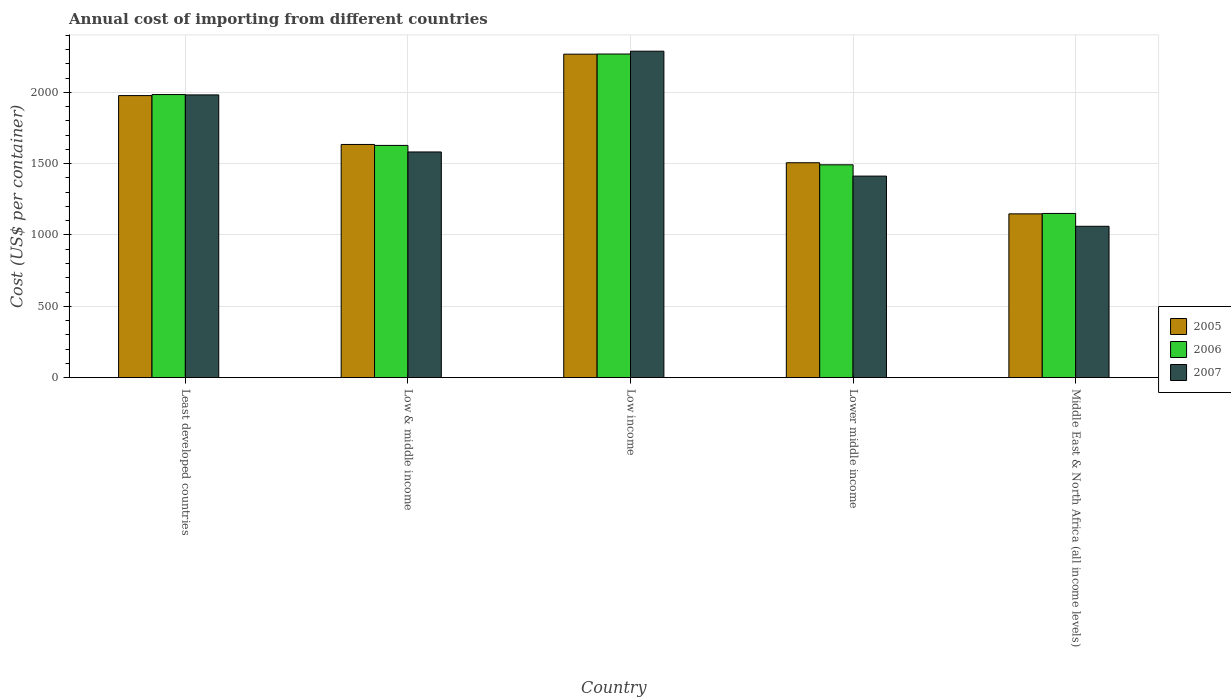How many different coloured bars are there?
Your answer should be compact. 3. How many bars are there on the 3rd tick from the right?
Your answer should be very brief. 3. What is the total annual cost of importing in 2006 in Middle East & North Africa (all income levels)?
Offer a terse response. 1151.06. Across all countries, what is the maximum total annual cost of importing in 2007?
Offer a terse response. 2288.29. Across all countries, what is the minimum total annual cost of importing in 2007?
Give a very brief answer. 1061. In which country was the total annual cost of importing in 2005 minimum?
Offer a very short reply. Middle East & North Africa (all income levels). What is the total total annual cost of importing in 2006 in the graph?
Your answer should be compact. 8523.89. What is the difference between the total annual cost of importing in 2007 in Lower middle income and that in Middle East & North Africa (all income levels)?
Offer a very short reply. 351.82. What is the difference between the total annual cost of importing in 2007 in Least developed countries and the total annual cost of importing in 2005 in Middle East & North Africa (all income levels)?
Keep it short and to the point. 833.76. What is the average total annual cost of importing in 2006 per country?
Your answer should be compact. 1704.78. What is the difference between the total annual cost of importing of/in 2005 and total annual cost of importing of/in 2007 in Low & middle income?
Offer a terse response. 52.49. What is the ratio of the total annual cost of importing in 2007 in Least developed countries to that in Middle East & North Africa (all income levels)?
Offer a terse response. 1.87. Is the difference between the total annual cost of importing in 2005 in Least developed countries and Lower middle income greater than the difference between the total annual cost of importing in 2007 in Least developed countries and Lower middle income?
Offer a terse response. No. What is the difference between the highest and the second highest total annual cost of importing in 2006?
Give a very brief answer. 356.5. What is the difference between the highest and the lowest total annual cost of importing in 2005?
Offer a very short reply. 1119.25. In how many countries, is the total annual cost of importing in 2006 greater than the average total annual cost of importing in 2006 taken over all countries?
Provide a short and direct response. 2. What does the 2nd bar from the right in Lower middle income represents?
Make the answer very short. 2006. How many countries are there in the graph?
Your response must be concise. 5. What is the difference between two consecutive major ticks on the Y-axis?
Keep it short and to the point. 500. Are the values on the major ticks of Y-axis written in scientific E-notation?
Your answer should be very brief. No. How many legend labels are there?
Make the answer very short. 3. What is the title of the graph?
Keep it short and to the point. Annual cost of importing from different countries. Does "2007" appear as one of the legend labels in the graph?
Provide a succinct answer. Yes. What is the label or title of the Y-axis?
Your answer should be compact. Cost (US$ per container). What is the Cost (US$ per container) of 2005 in Least developed countries?
Give a very brief answer. 1977.19. What is the Cost (US$ per container) in 2006 in Least developed countries?
Offer a very short reply. 1984.41. What is the Cost (US$ per container) of 2007 in Least developed countries?
Your answer should be very brief. 1982. What is the Cost (US$ per container) of 2005 in Low & middle income?
Your response must be concise. 1634.54. What is the Cost (US$ per container) of 2006 in Low & middle income?
Provide a succinct answer. 1627.91. What is the Cost (US$ per container) in 2007 in Low & middle income?
Give a very brief answer. 1582.06. What is the Cost (US$ per container) of 2005 in Low income?
Offer a very short reply. 2267.48. What is the Cost (US$ per container) of 2006 in Low income?
Offer a very short reply. 2268.46. What is the Cost (US$ per container) of 2007 in Low income?
Ensure brevity in your answer.  2288.29. What is the Cost (US$ per container) of 2005 in Lower middle income?
Offer a very short reply. 1506.43. What is the Cost (US$ per container) in 2006 in Lower middle income?
Your response must be concise. 1492.04. What is the Cost (US$ per container) of 2007 in Lower middle income?
Offer a terse response. 1412.82. What is the Cost (US$ per container) in 2005 in Middle East & North Africa (all income levels)?
Make the answer very short. 1148.24. What is the Cost (US$ per container) in 2006 in Middle East & North Africa (all income levels)?
Provide a short and direct response. 1151.06. What is the Cost (US$ per container) of 2007 in Middle East & North Africa (all income levels)?
Ensure brevity in your answer.  1061. Across all countries, what is the maximum Cost (US$ per container) in 2005?
Offer a very short reply. 2267.48. Across all countries, what is the maximum Cost (US$ per container) of 2006?
Provide a short and direct response. 2268.46. Across all countries, what is the maximum Cost (US$ per container) in 2007?
Offer a terse response. 2288.29. Across all countries, what is the minimum Cost (US$ per container) of 2005?
Give a very brief answer. 1148.24. Across all countries, what is the minimum Cost (US$ per container) in 2006?
Your answer should be compact. 1151.06. Across all countries, what is the minimum Cost (US$ per container) of 2007?
Provide a succinct answer. 1061. What is the total Cost (US$ per container) in 2005 in the graph?
Your response must be concise. 8533.88. What is the total Cost (US$ per container) of 2006 in the graph?
Ensure brevity in your answer.  8523.89. What is the total Cost (US$ per container) in 2007 in the graph?
Your response must be concise. 8326.16. What is the difference between the Cost (US$ per container) in 2005 in Least developed countries and that in Low & middle income?
Your answer should be compact. 342.64. What is the difference between the Cost (US$ per container) of 2006 in Least developed countries and that in Low & middle income?
Keep it short and to the point. 356.5. What is the difference between the Cost (US$ per container) of 2007 in Least developed countries and that in Low & middle income?
Ensure brevity in your answer.  399.94. What is the difference between the Cost (US$ per container) of 2005 in Least developed countries and that in Low income?
Offer a very short reply. -290.3. What is the difference between the Cost (US$ per container) in 2006 in Least developed countries and that in Low income?
Offer a very short reply. -284.06. What is the difference between the Cost (US$ per container) in 2007 in Least developed countries and that in Low income?
Ensure brevity in your answer.  -306.29. What is the difference between the Cost (US$ per container) in 2005 in Least developed countries and that in Lower middle income?
Keep it short and to the point. 470.76. What is the difference between the Cost (US$ per container) of 2006 in Least developed countries and that in Lower middle income?
Ensure brevity in your answer.  492.37. What is the difference between the Cost (US$ per container) of 2007 in Least developed countries and that in Lower middle income?
Provide a short and direct response. 569.18. What is the difference between the Cost (US$ per container) in 2005 in Least developed countries and that in Middle East & North Africa (all income levels)?
Offer a very short reply. 828.95. What is the difference between the Cost (US$ per container) in 2006 in Least developed countries and that in Middle East & North Africa (all income levels)?
Offer a very short reply. 833.35. What is the difference between the Cost (US$ per container) in 2007 in Least developed countries and that in Middle East & North Africa (all income levels)?
Provide a succinct answer. 921. What is the difference between the Cost (US$ per container) of 2005 in Low & middle income and that in Low income?
Offer a terse response. -632.94. What is the difference between the Cost (US$ per container) of 2006 in Low & middle income and that in Low income?
Your response must be concise. -640.55. What is the difference between the Cost (US$ per container) of 2007 in Low & middle income and that in Low income?
Ensure brevity in your answer.  -706.23. What is the difference between the Cost (US$ per container) in 2005 in Low & middle income and that in Lower middle income?
Provide a succinct answer. 128.12. What is the difference between the Cost (US$ per container) of 2006 in Low & middle income and that in Lower middle income?
Provide a succinct answer. 135.87. What is the difference between the Cost (US$ per container) of 2007 in Low & middle income and that in Lower middle income?
Offer a terse response. 169.24. What is the difference between the Cost (US$ per container) of 2005 in Low & middle income and that in Middle East & North Africa (all income levels)?
Give a very brief answer. 486.31. What is the difference between the Cost (US$ per container) of 2006 in Low & middle income and that in Middle East & North Africa (all income levels)?
Provide a succinct answer. 476.85. What is the difference between the Cost (US$ per container) in 2007 in Low & middle income and that in Middle East & North Africa (all income levels)?
Make the answer very short. 521.06. What is the difference between the Cost (US$ per container) of 2005 in Low income and that in Lower middle income?
Provide a short and direct response. 761.05. What is the difference between the Cost (US$ per container) of 2006 in Low income and that in Lower middle income?
Keep it short and to the point. 776.42. What is the difference between the Cost (US$ per container) of 2007 in Low income and that in Lower middle income?
Make the answer very short. 875.47. What is the difference between the Cost (US$ per container) in 2005 in Low income and that in Middle East & North Africa (all income levels)?
Offer a terse response. 1119.25. What is the difference between the Cost (US$ per container) of 2006 in Low income and that in Middle East & North Africa (all income levels)?
Offer a very short reply. 1117.41. What is the difference between the Cost (US$ per container) in 2007 in Low income and that in Middle East & North Africa (all income levels)?
Offer a terse response. 1227.29. What is the difference between the Cost (US$ per container) of 2005 in Lower middle income and that in Middle East & North Africa (all income levels)?
Offer a very short reply. 358.19. What is the difference between the Cost (US$ per container) of 2006 in Lower middle income and that in Middle East & North Africa (all income levels)?
Ensure brevity in your answer.  340.98. What is the difference between the Cost (US$ per container) in 2007 in Lower middle income and that in Middle East & North Africa (all income levels)?
Your answer should be very brief. 351.82. What is the difference between the Cost (US$ per container) in 2005 in Least developed countries and the Cost (US$ per container) in 2006 in Low & middle income?
Provide a short and direct response. 349.27. What is the difference between the Cost (US$ per container) in 2005 in Least developed countries and the Cost (US$ per container) in 2007 in Low & middle income?
Keep it short and to the point. 395.13. What is the difference between the Cost (US$ per container) of 2006 in Least developed countries and the Cost (US$ per container) of 2007 in Low & middle income?
Make the answer very short. 402.35. What is the difference between the Cost (US$ per container) in 2005 in Least developed countries and the Cost (US$ per container) in 2006 in Low income?
Provide a short and direct response. -291.28. What is the difference between the Cost (US$ per container) in 2005 in Least developed countries and the Cost (US$ per container) in 2007 in Low income?
Keep it short and to the point. -311.1. What is the difference between the Cost (US$ per container) of 2006 in Least developed countries and the Cost (US$ per container) of 2007 in Low income?
Keep it short and to the point. -303.88. What is the difference between the Cost (US$ per container) in 2005 in Least developed countries and the Cost (US$ per container) in 2006 in Lower middle income?
Ensure brevity in your answer.  485.15. What is the difference between the Cost (US$ per container) of 2005 in Least developed countries and the Cost (US$ per container) of 2007 in Lower middle income?
Provide a succinct answer. 564.37. What is the difference between the Cost (US$ per container) of 2006 in Least developed countries and the Cost (US$ per container) of 2007 in Lower middle income?
Your answer should be compact. 571.59. What is the difference between the Cost (US$ per container) of 2005 in Least developed countries and the Cost (US$ per container) of 2006 in Middle East & North Africa (all income levels)?
Provide a short and direct response. 826.13. What is the difference between the Cost (US$ per container) in 2005 in Least developed countries and the Cost (US$ per container) in 2007 in Middle East & North Africa (all income levels)?
Your answer should be very brief. 916.19. What is the difference between the Cost (US$ per container) in 2006 in Least developed countries and the Cost (US$ per container) in 2007 in Middle East & North Africa (all income levels)?
Provide a succinct answer. 923.41. What is the difference between the Cost (US$ per container) in 2005 in Low & middle income and the Cost (US$ per container) in 2006 in Low income?
Provide a short and direct response. -633.92. What is the difference between the Cost (US$ per container) in 2005 in Low & middle income and the Cost (US$ per container) in 2007 in Low income?
Give a very brief answer. -653.74. What is the difference between the Cost (US$ per container) of 2006 in Low & middle income and the Cost (US$ per container) of 2007 in Low income?
Offer a very short reply. -660.37. What is the difference between the Cost (US$ per container) of 2005 in Low & middle income and the Cost (US$ per container) of 2006 in Lower middle income?
Ensure brevity in your answer.  142.5. What is the difference between the Cost (US$ per container) in 2005 in Low & middle income and the Cost (US$ per container) in 2007 in Lower middle income?
Provide a succinct answer. 221.73. What is the difference between the Cost (US$ per container) of 2006 in Low & middle income and the Cost (US$ per container) of 2007 in Lower middle income?
Your answer should be compact. 215.1. What is the difference between the Cost (US$ per container) of 2005 in Low & middle income and the Cost (US$ per container) of 2006 in Middle East & North Africa (all income levels)?
Keep it short and to the point. 483.49. What is the difference between the Cost (US$ per container) of 2005 in Low & middle income and the Cost (US$ per container) of 2007 in Middle East & North Africa (all income levels)?
Your answer should be very brief. 573.54. What is the difference between the Cost (US$ per container) of 2006 in Low & middle income and the Cost (US$ per container) of 2007 in Middle East & North Africa (all income levels)?
Provide a short and direct response. 566.91. What is the difference between the Cost (US$ per container) in 2005 in Low income and the Cost (US$ per container) in 2006 in Lower middle income?
Give a very brief answer. 775.44. What is the difference between the Cost (US$ per container) of 2005 in Low income and the Cost (US$ per container) of 2007 in Lower middle income?
Make the answer very short. 854.67. What is the difference between the Cost (US$ per container) of 2006 in Low income and the Cost (US$ per container) of 2007 in Lower middle income?
Give a very brief answer. 855.65. What is the difference between the Cost (US$ per container) in 2005 in Low income and the Cost (US$ per container) in 2006 in Middle East & North Africa (all income levels)?
Your answer should be very brief. 1116.42. What is the difference between the Cost (US$ per container) of 2005 in Low income and the Cost (US$ per container) of 2007 in Middle East & North Africa (all income levels)?
Keep it short and to the point. 1206.48. What is the difference between the Cost (US$ per container) of 2006 in Low income and the Cost (US$ per container) of 2007 in Middle East & North Africa (all income levels)?
Ensure brevity in your answer.  1207.46. What is the difference between the Cost (US$ per container) in 2005 in Lower middle income and the Cost (US$ per container) in 2006 in Middle East & North Africa (all income levels)?
Your response must be concise. 355.37. What is the difference between the Cost (US$ per container) in 2005 in Lower middle income and the Cost (US$ per container) in 2007 in Middle East & North Africa (all income levels)?
Ensure brevity in your answer.  445.43. What is the difference between the Cost (US$ per container) of 2006 in Lower middle income and the Cost (US$ per container) of 2007 in Middle East & North Africa (all income levels)?
Offer a terse response. 431.04. What is the average Cost (US$ per container) in 2005 per country?
Provide a short and direct response. 1706.78. What is the average Cost (US$ per container) of 2006 per country?
Make the answer very short. 1704.78. What is the average Cost (US$ per container) in 2007 per country?
Give a very brief answer. 1665.23. What is the difference between the Cost (US$ per container) in 2005 and Cost (US$ per container) in 2006 in Least developed countries?
Your response must be concise. -7.22. What is the difference between the Cost (US$ per container) of 2005 and Cost (US$ per container) of 2007 in Least developed countries?
Ensure brevity in your answer.  -4.81. What is the difference between the Cost (US$ per container) in 2006 and Cost (US$ per container) in 2007 in Least developed countries?
Give a very brief answer. 2.41. What is the difference between the Cost (US$ per container) in 2005 and Cost (US$ per container) in 2006 in Low & middle income?
Your answer should be compact. 6.63. What is the difference between the Cost (US$ per container) in 2005 and Cost (US$ per container) in 2007 in Low & middle income?
Your answer should be compact. 52.49. What is the difference between the Cost (US$ per container) in 2006 and Cost (US$ per container) in 2007 in Low & middle income?
Offer a very short reply. 45.86. What is the difference between the Cost (US$ per container) of 2005 and Cost (US$ per container) of 2006 in Low income?
Ensure brevity in your answer.  -0.98. What is the difference between the Cost (US$ per container) of 2005 and Cost (US$ per container) of 2007 in Low income?
Your answer should be compact. -20.8. What is the difference between the Cost (US$ per container) in 2006 and Cost (US$ per container) in 2007 in Low income?
Keep it short and to the point. -19.82. What is the difference between the Cost (US$ per container) of 2005 and Cost (US$ per container) of 2006 in Lower middle income?
Provide a short and direct response. 14.39. What is the difference between the Cost (US$ per container) in 2005 and Cost (US$ per container) in 2007 in Lower middle income?
Keep it short and to the point. 93.61. What is the difference between the Cost (US$ per container) of 2006 and Cost (US$ per container) of 2007 in Lower middle income?
Make the answer very short. 79.22. What is the difference between the Cost (US$ per container) in 2005 and Cost (US$ per container) in 2006 in Middle East & North Africa (all income levels)?
Offer a terse response. -2.82. What is the difference between the Cost (US$ per container) of 2005 and Cost (US$ per container) of 2007 in Middle East & North Africa (all income levels)?
Provide a short and direct response. 87.24. What is the difference between the Cost (US$ per container) of 2006 and Cost (US$ per container) of 2007 in Middle East & North Africa (all income levels)?
Provide a succinct answer. 90.06. What is the ratio of the Cost (US$ per container) of 2005 in Least developed countries to that in Low & middle income?
Offer a very short reply. 1.21. What is the ratio of the Cost (US$ per container) of 2006 in Least developed countries to that in Low & middle income?
Give a very brief answer. 1.22. What is the ratio of the Cost (US$ per container) of 2007 in Least developed countries to that in Low & middle income?
Ensure brevity in your answer.  1.25. What is the ratio of the Cost (US$ per container) in 2005 in Least developed countries to that in Low income?
Your response must be concise. 0.87. What is the ratio of the Cost (US$ per container) of 2006 in Least developed countries to that in Low income?
Offer a terse response. 0.87. What is the ratio of the Cost (US$ per container) of 2007 in Least developed countries to that in Low income?
Give a very brief answer. 0.87. What is the ratio of the Cost (US$ per container) of 2005 in Least developed countries to that in Lower middle income?
Give a very brief answer. 1.31. What is the ratio of the Cost (US$ per container) of 2006 in Least developed countries to that in Lower middle income?
Make the answer very short. 1.33. What is the ratio of the Cost (US$ per container) of 2007 in Least developed countries to that in Lower middle income?
Offer a very short reply. 1.4. What is the ratio of the Cost (US$ per container) in 2005 in Least developed countries to that in Middle East & North Africa (all income levels)?
Your answer should be very brief. 1.72. What is the ratio of the Cost (US$ per container) of 2006 in Least developed countries to that in Middle East & North Africa (all income levels)?
Your answer should be compact. 1.72. What is the ratio of the Cost (US$ per container) of 2007 in Least developed countries to that in Middle East & North Africa (all income levels)?
Your answer should be compact. 1.87. What is the ratio of the Cost (US$ per container) in 2005 in Low & middle income to that in Low income?
Ensure brevity in your answer.  0.72. What is the ratio of the Cost (US$ per container) in 2006 in Low & middle income to that in Low income?
Your answer should be very brief. 0.72. What is the ratio of the Cost (US$ per container) of 2007 in Low & middle income to that in Low income?
Your response must be concise. 0.69. What is the ratio of the Cost (US$ per container) of 2005 in Low & middle income to that in Lower middle income?
Keep it short and to the point. 1.08. What is the ratio of the Cost (US$ per container) of 2006 in Low & middle income to that in Lower middle income?
Provide a succinct answer. 1.09. What is the ratio of the Cost (US$ per container) of 2007 in Low & middle income to that in Lower middle income?
Provide a short and direct response. 1.12. What is the ratio of the Cost (US$ per container) in 2005 in Low & middle income to that in Middle East & North Africa (all income levels)?
Offer a terse response. 1.42. What is the ratio of the Cost (US$ per container) in 2006 in Low & middle income to that in Middle East & North Africa (all income levels)?
Give a very brief answer. 1.41. What is the ratio of the Cost (US$ per container) of 2007 in Low & middle income to that in Middle East & North Africa (all income levels)?
Offer a terse response. 1.49. What is the ratio of the Cost (US$ per container) in 2005 in Low income to that in Lower middle income?
Ensure brevity in your answer.  1.51. What is the ratio of the Cost (US$ per container) of 2006 in Low income to that in Lower middle income?
Offer a terse response. 1.52. What is the ratio of the Cost (US$ per container) in 2007 in Low income to that in Lower middle income?
Your answer should be compact. 1.62. What is the ratio of the Cost (US$ per container) in 2005 in Low income to that in Middle East & North Africa (all income levels)?
Your answer should be compact. 1.97. What is the ratio of the Cost (US$ per container) of 2006 in Low income to that in Middle East & North Africa (all income levels)?
Provide a short and direct response. 1.97. What is the ratio of the Cost (US$ per container) of 2007 in Low income to that in Middle East & North Africa (all income levels)?
Provide a short and direct response. 2.16. What is the ratio of the Cost (US$ per container) in 2005 in Lower middle income to that in Middle East & North Africa (all income levels)?
Provide a short and direct response. 1.31. What is the ratio of the Cost (US$ per container) of 2006 in Lower middle income to that in Middle East & North Africa (all income levels)?
Provide a succinct answer. 1.3. What is the ratio of the Cost (US$ per container) of 2007 in Lower middle income to that in Middle East & North Africa (all income levels)?
Provide a short and direct response. 1.33. What is the difference between the highest and the second highest Cost (US$ per container) of 2005?
Your answer should be very brief. 290.3. What is the difference between the highest and the second highest Cost (US$ per container) in 2006?
Keep it short and to the point. 284.06. What is the difference between the highest and the second highest Cost (US$ per container) of 2007?
Your response must be concise. 306.29. What is the difference between the highest and the lowest Cost (US$ per container) of 2005?
Make the answer very short. 1119.25. What is the difference between the highest and the lowest Cost (US$ per container) in 2006?
Your answer should be very brief. 1117.41. What is the difference between the highest and the lowest Cost (US$ per container) in 2007?
Ensure brevity in your answer.  1227.29. 